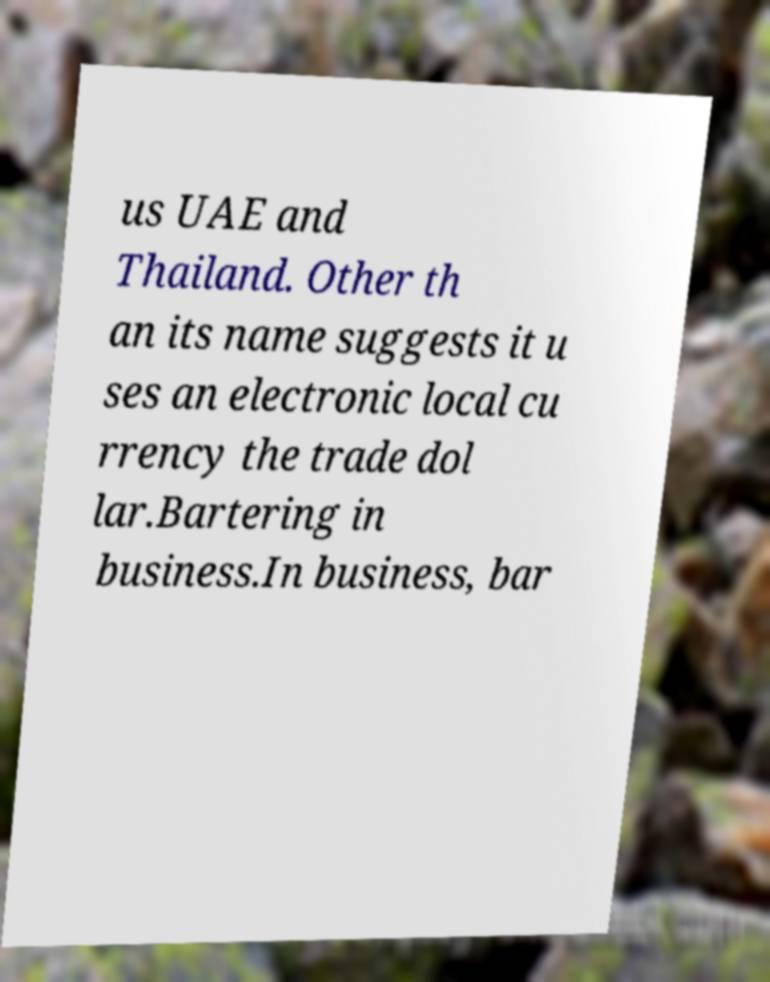Please read and relay the text visible in this image. What does it say? us UAE and Thailand. Other th an its name suggests it u ses an electronic local cu rrency the trade dol lar.Bartering in business.In business, bar 